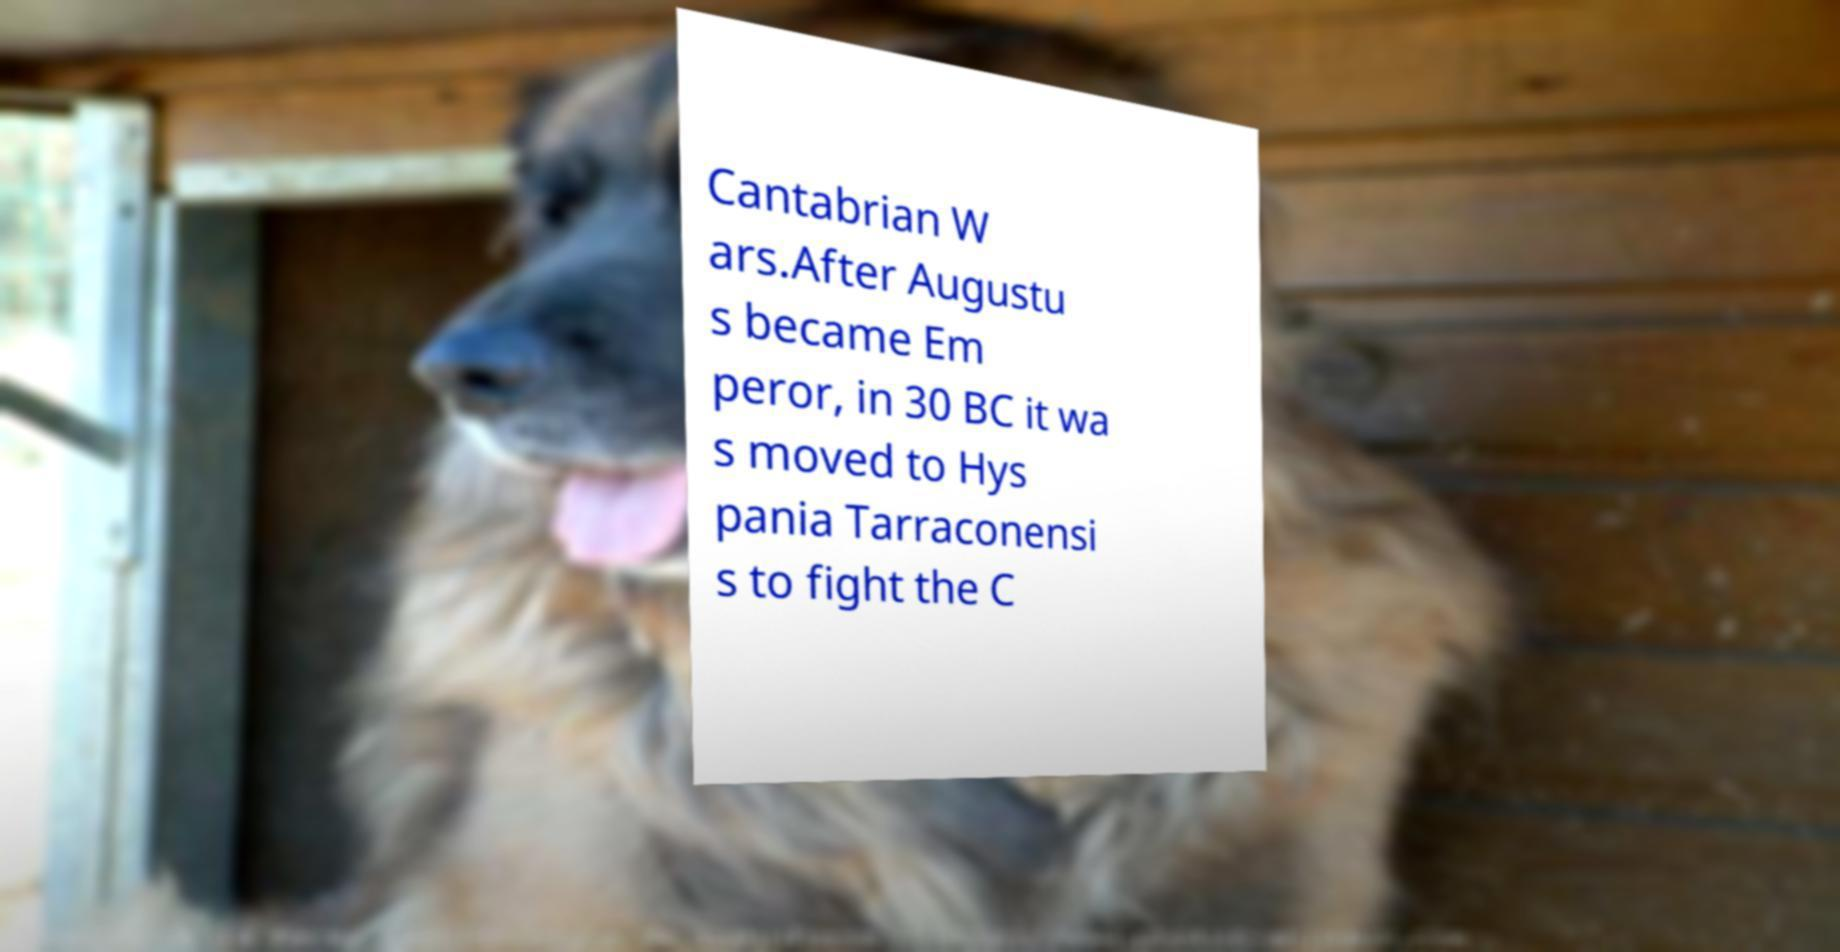What messages or text are displayed in this image? I need them in a readable, typed format. Cantabrian W ars.After Augustu s became Em peror, in 30 BC it wa s moved to Hys pania Tarraconensi s to fight the C 